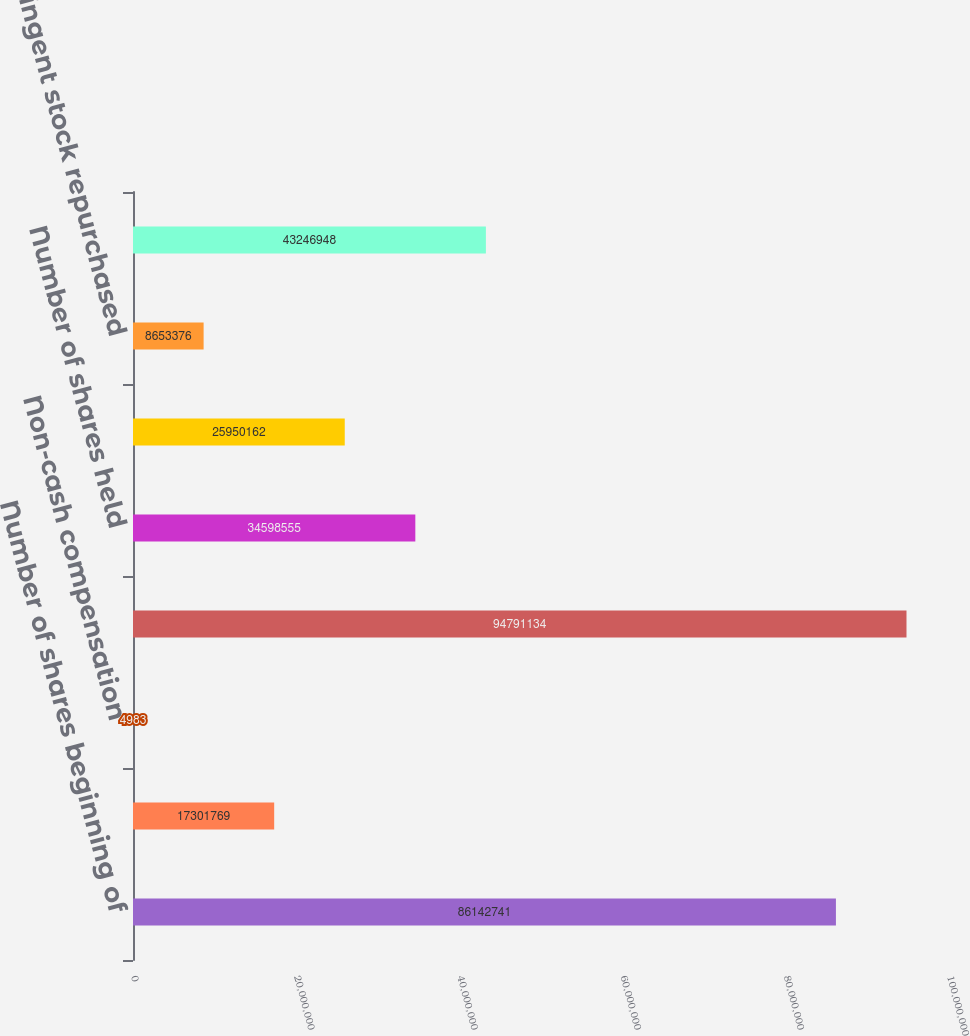Convert chart. <chart><loc_0><loc_0><loc_500><loc_500><bar_chart><fcel>Number of shares beginning of<fcel>Shares issued for contingent<fcel>Non-cash compensation<fcel>Number of shares issued end of<fcel>Number of shares held<fcel>Purchase of shares during the<fcel>Contingent stock repurchased<fcel>Number of shares held end of<nl><fcel>8.61427e+07<fcel>1.73018e+07<fcel>4983<fcel>9.47911e+07<fcel>3.45986e+07<fcel>2.59502e+07<fcel>8.65338e+06<fcel>4.32469e+07<nl></chart> 